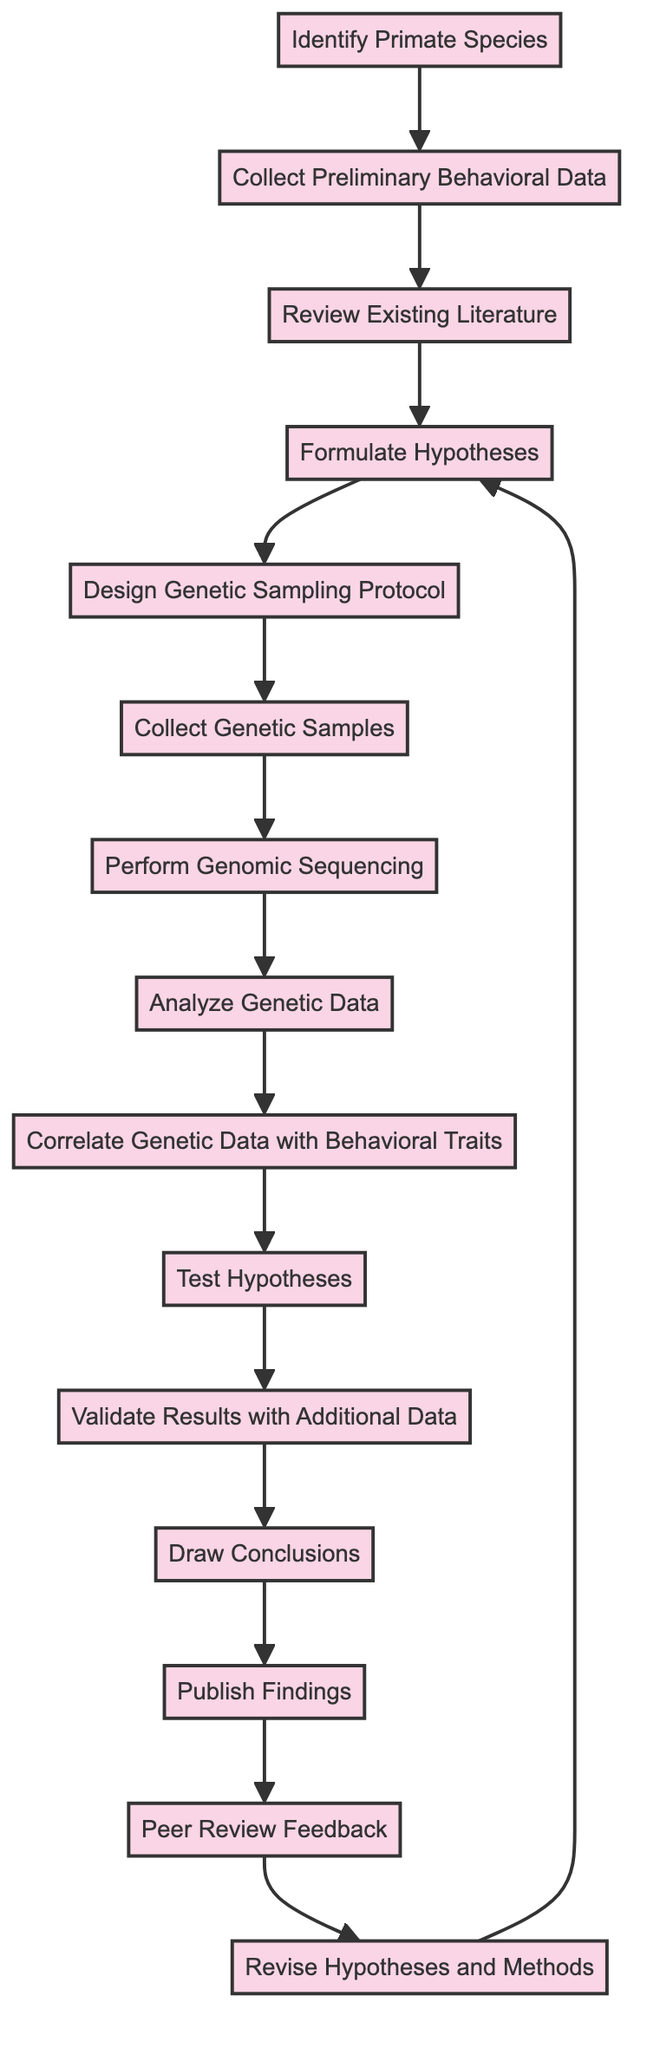What is the first activity in the process? The first activity is "Identify Primate Species," which is the starting point of the diagram.
Answer: Identify Primate Species How many activities are in the diagram? By counting the individual activities listed from the start to the end of the process, there are a total of 14 activities represented in the diagram.
Answer: 14 Which activity follows "Review Existing Literature"? According to the flow of the diagram, the activity that follows "Review Existing Literature" is "Formulate Hypotheses."
Answer: Formulate Hypotheses What is the last activity in the process? The last activity depicted in the diagram is "Revise Hypotheses and Methods," which loops back to "Formulate Hypotheses."
Answer: Revise Hypotheses and Methods What activities lead to data analysis? The activities leading to data analysis include "Collect Genetic Samples," "Perform Genomic Sequencing," and "Analyze Genetic Data," which are sequentially connected in the process.
Answer: Collect Genetic Samples, Perform Genomic Sequencing, Analyze Genetic Data What is the relationship between "Test Hypotheses" and "Validate Results with Additional Data"? "Test Hypotheses" is a prerequisite activity that must be completed before moving on to "Validate Results with Additional Data," indicating a direct sequence in the process.
Answer: Sequential relationship How many times does "Revise Hypotheses and Methods" connect back to the diagram? "Revise Hypotheses and Methods" connects back to "Formulate Hypotheses" once, indicating a cyclical review process to refine the hypotheses based on feedback and findings.
Answer: Once Which activity involves correlating genetic and behavioral traits? The activity that specifically involves correlating genetic data with behavioral traits is "Correlate Genetic Data with Behavioral Traits."
Answer: Correlate Genetic Data with Behavioral Traits What occurs after "Publish Findings"? After "Publish Findings," the next step in the process is "Peer Review Feedback," which is an essential part of scientific publishing.
Answer: Peer Review Feedback 